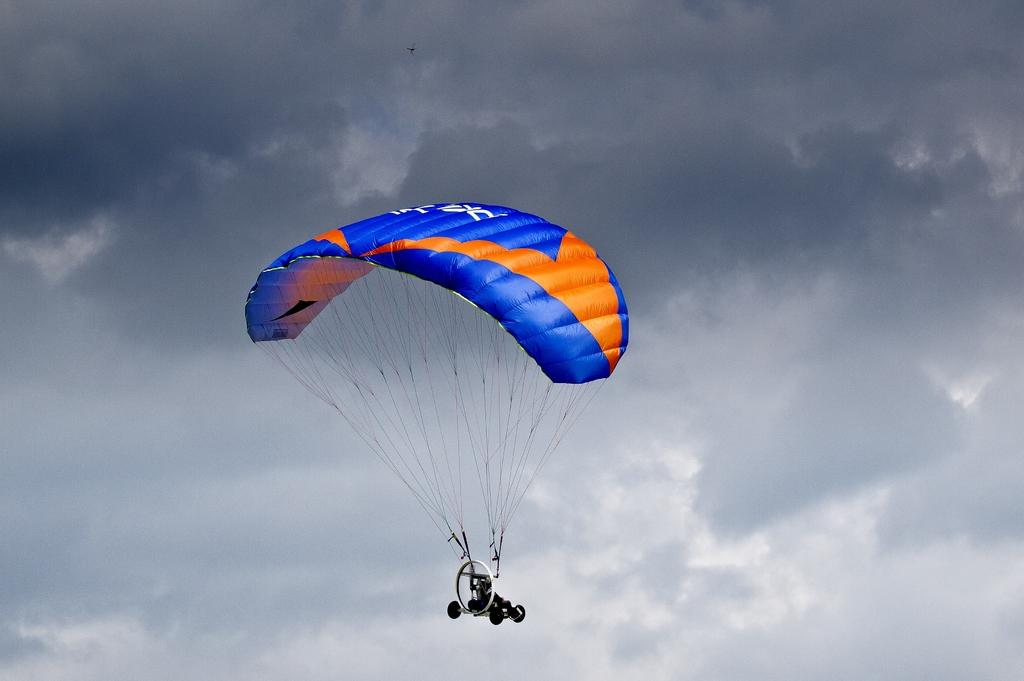What is the main object in the image? There is a parachute in the image. Can you describe the person in the image? A human is visible in the image. What is the weather like in the image? The sky is cloudy in the image. What colors are used for the parachute? The parachute is blue and orange in color. What type of crime is being committed in the image? There is no crime being committed in the image; it features a person with a parachute in a cloudy sky. What kind of trouble is the person in the image facing? There is no indication of trouble in the image; the person is simply visible with a parachute in a cloudy sky. 